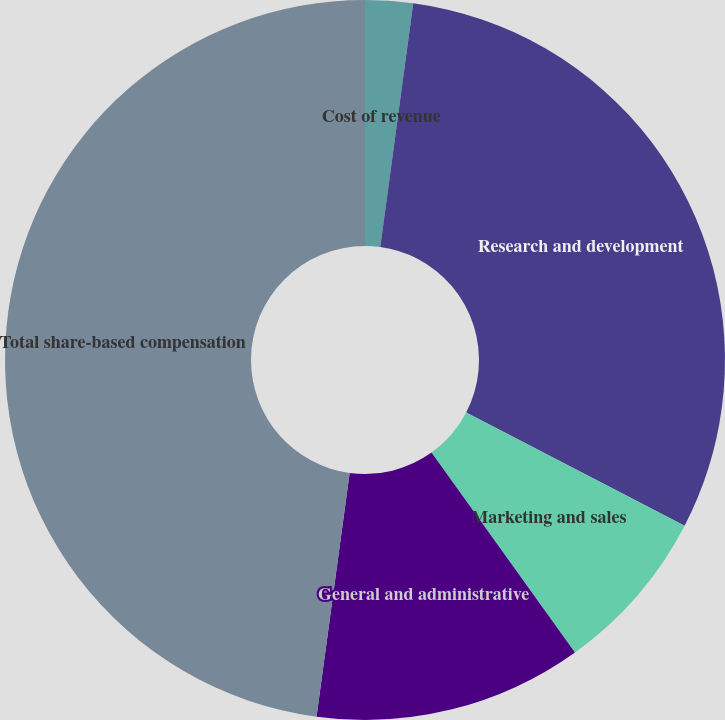Convert chart. <chart><loc_0><loc_0><loc_500><loc_500><pie_chart><fcel>Cost of revenue<fcel>Research and development<fcel>Marketing and sales<fcel>General and administrative<fcel>Total share-based compensation<nl><fcel>2.14%<fcel>30.47%<fcel>7.48%<fcel>12.06%<fcel>47.85%<nl></chart> 